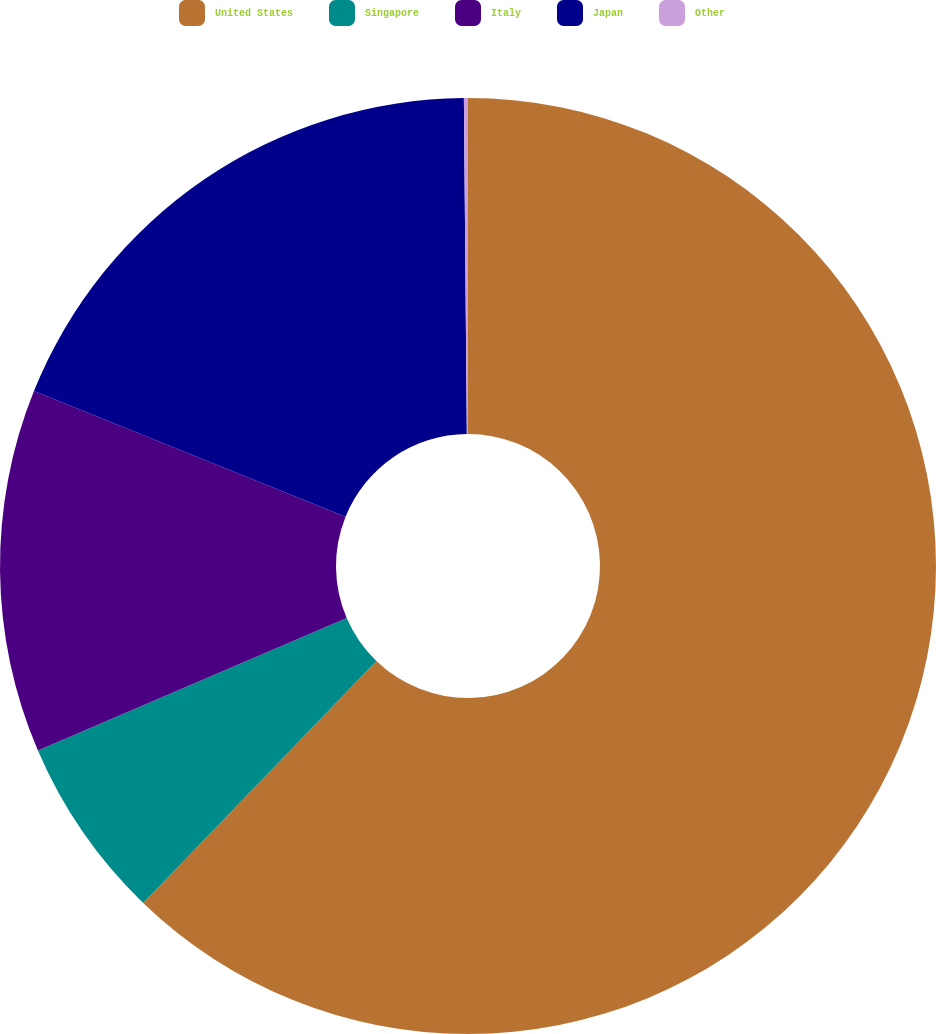Convert chart. <chart><loc_0><loc_0><loc_500><loc_500><pie_chart><fcel>United States<fcel>Singapore<fcel>Italy<fcel>Japan<fcel>Other<nl><fcel>62.21%<fcel>6.34%<fcel>12.55%<fcel>18.76%<fcel>0.14%<nl></chart> 